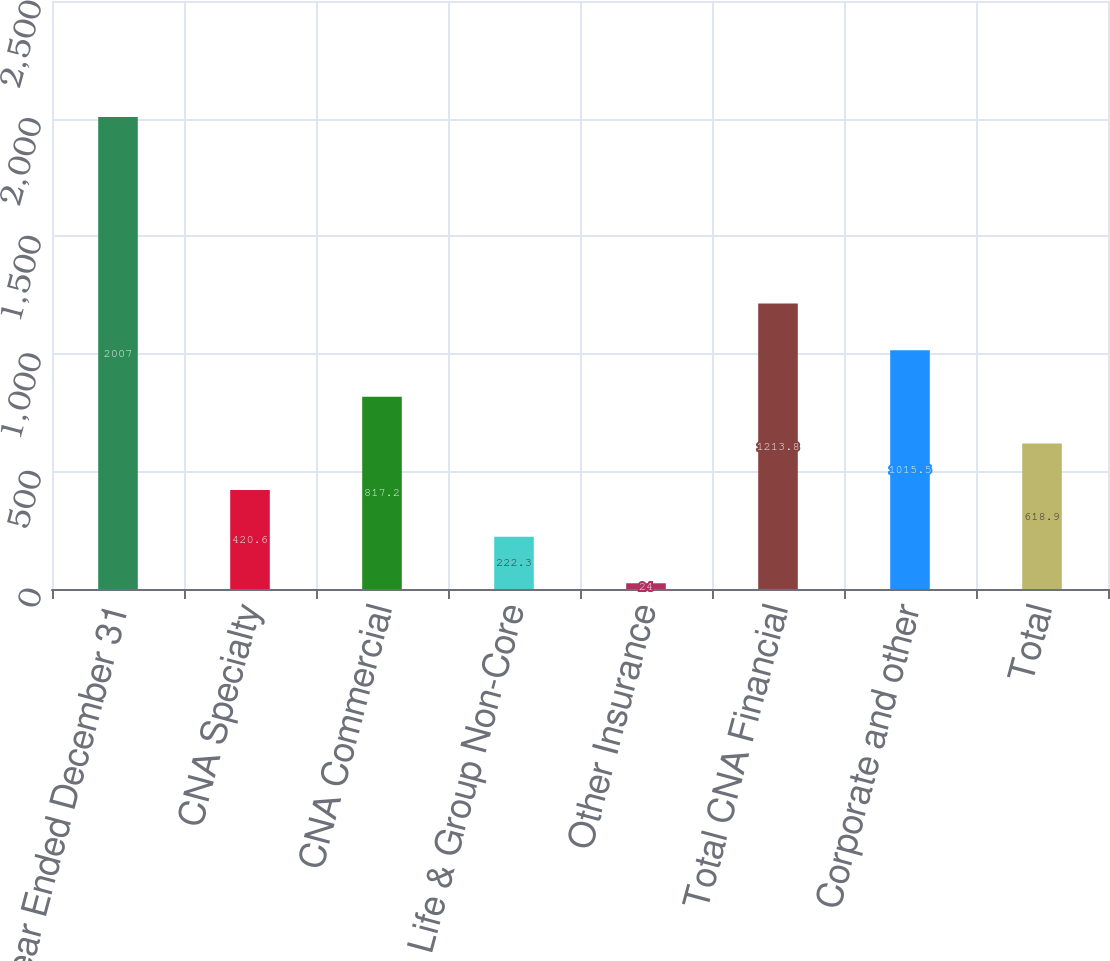<chart> <loc_0><loc_0><loc_500><loc_500><bar_chart><fcel>Year Ended December 31<fcel>CNA Specialty<fcel>CNA Commercial<fcel>Life & Group Non-Core<fcel>Other Insurance<fcel>Total CNA Financial<fcel>Corporate and other<fcel>Total<nl><fcel>2007<fcel>420.6<fcel>817.2<fcel>222.3<fcel>24<fcel>1213.8<fcel>1015.5<fcel>618.9<nl></chart> 